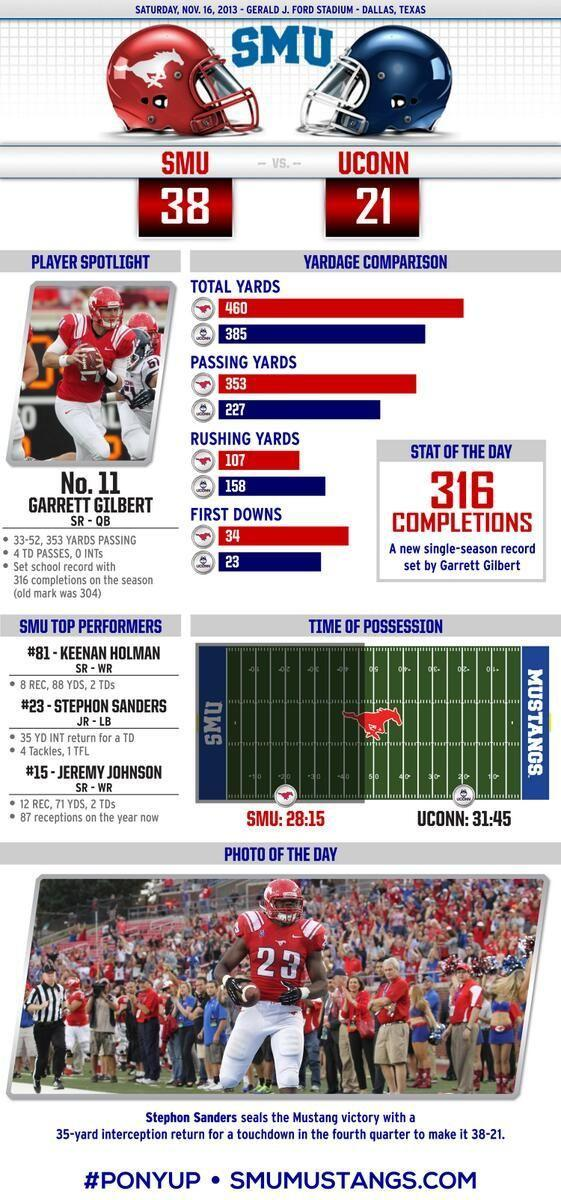Which animal is depicted on the red helmet- horse, elephant or rabbit?
Answer the question with a short phrase. horse Which player is shown at the bottom? Stephon Sanders 